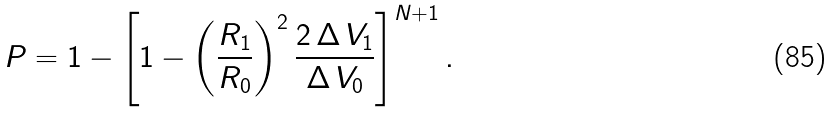<formula> <loc_0><loc_0><loc_500><loc_500>P = 1 - \left [ 1 - \left ( \frac { R _ { 1 } } { R _ { 0 } } \right ) ^ { 2 } \frac { 2 \, \Delta \, V _ { 1 } } { \Delta \, V _ { 0 } } \right ] ^ { N + 1 } .</formula> 